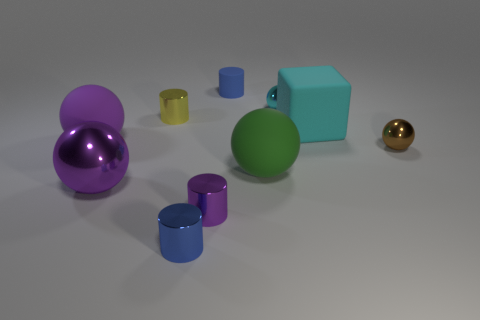What is the size of the other matte object that is the same shape as the purple matte object?
Offer a very short reply. Large. Do the blue thing in front of the tiny blue matte object and the tiny purple metallic thing have the same shape?
Provide a succinct answer. Yes. There is a large matte object that is on the right side of the metallic thing that is behind the small yellow metallic thing; what is its shape?
Offer a very short reply. Cube. Is there anything else that has the same shape as the big cyan rubber thing?
Make the answer very short. No. There is another large rubber thing that is the same shape as the purple rubber thing; what color is it?
Make the answer very short. Green. There is a rubber cube; does it have the same color as the tiny shiny ball behind the yellow metal thing?
Offer a terse response. Yes. There is a shiny thing that is behind the green object and on the left side of the blue matte cylinder; what shape is it?
Provide a succinct answer. Cylinder. Are there fewer small metal cylinders than green matte things?
Give a very brief answer. No. Is there a big shiny ball?
Offer a very short reply. Yes. What number of other things are there of the same size as the cyan ball?
Ensure brevity in your answer.  5. 